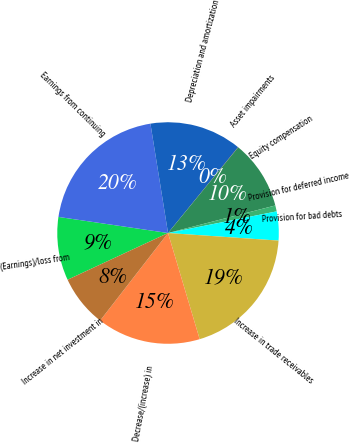<chart> <loc_0><loc_0><loc_500><loc_500><pie_chart><fcel>(Earnings)/loss from<fcel>Earnings from continuing<fcel>Depreciation and amortization<fcel>Asset impairments<fcel>Equity compensation<fcel>Provision for deferred income<fcel>Provision for bad debts<fcel>Increase in trade receivables<fcel>Decrease/(increase) in<fcel>Increase in net investment in<nl><fcel>9.25%<fcel>20.14%<fcel>13.43%<fcel>0.03%<fcel>10.08%<fcel>0.87%<fcel>4.22%<fcel>19.3%<fcel>15.11%<fcel>7.57%<nl></chart> 